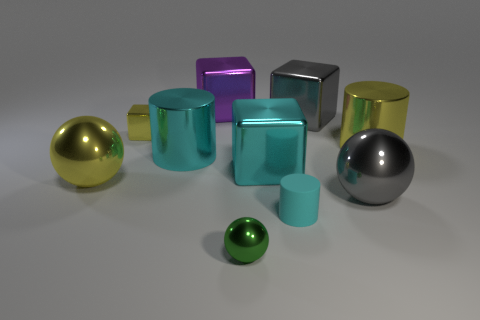Subtract all cylinders. How many objects are left? 7 Add 5 large cyan metallic cylinders. How many large cyan metallic cylinders are left? 6 Add 2 green rubber things. How many green rubber things exist? 2 Subtract 1 gray balls. How many objects are left? 9 Subtract all big brown cylinders. Subtract all green shiny balls. How many objects are left? 9 